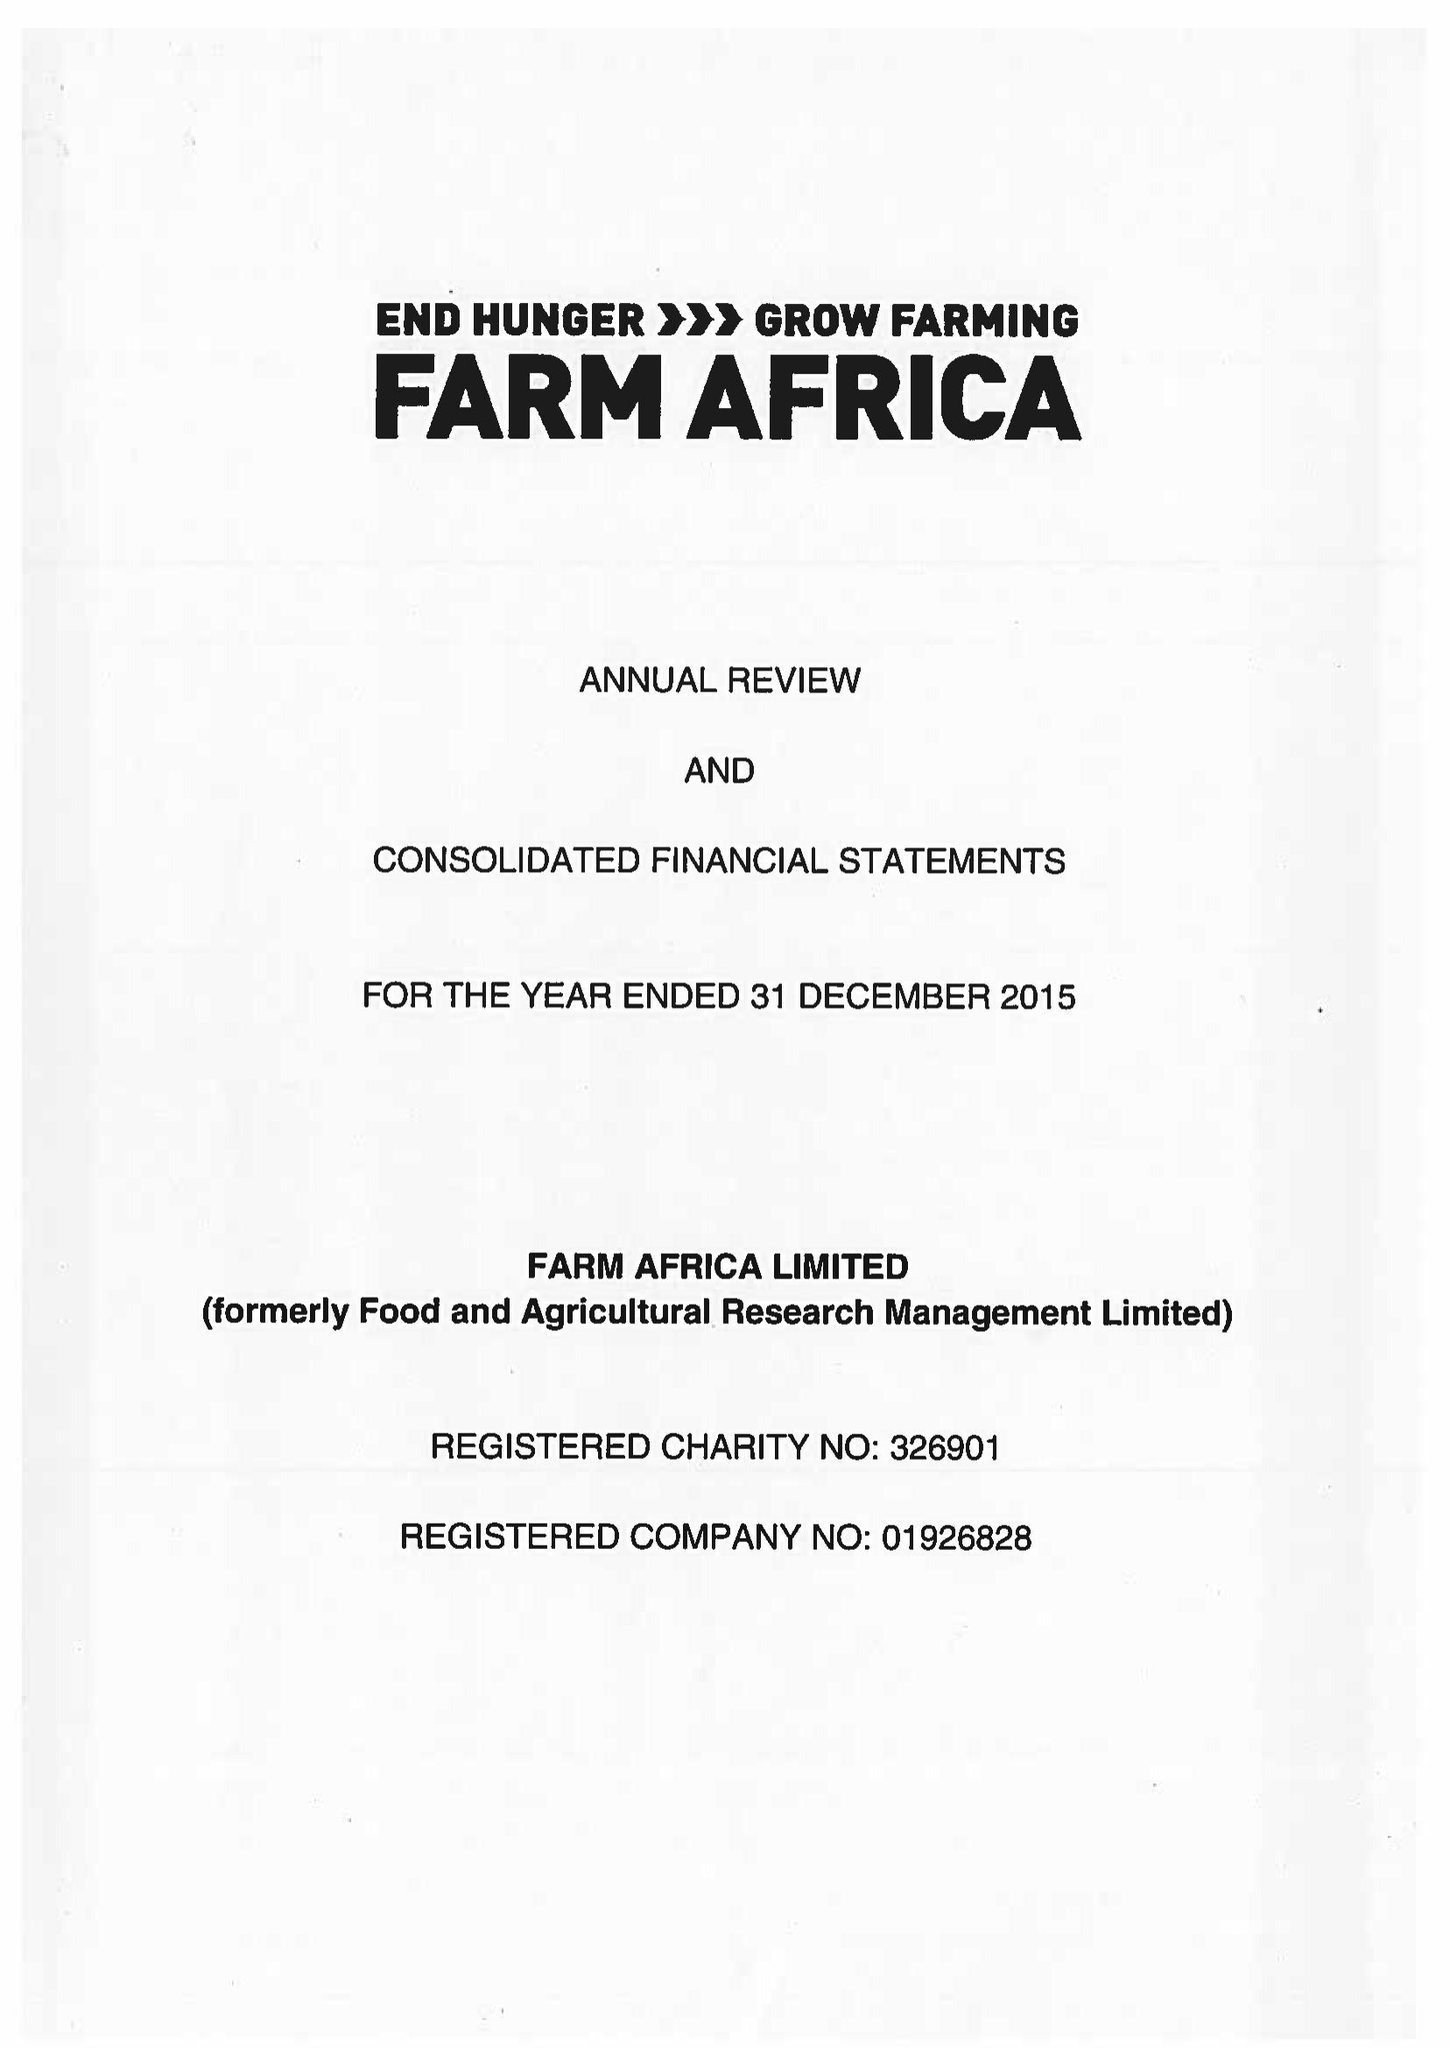What is the value for the spending_annually_in_british_pounds?
Answer the question using a single word or phrase. 12683000.00 